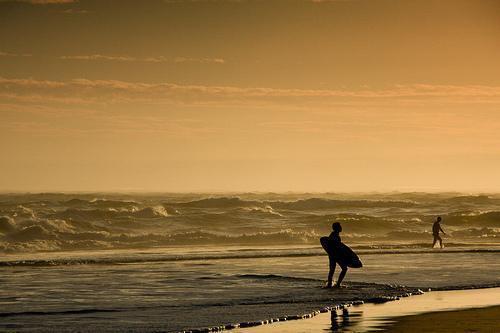How many people are shown?
Give a very brief answer. 2. 